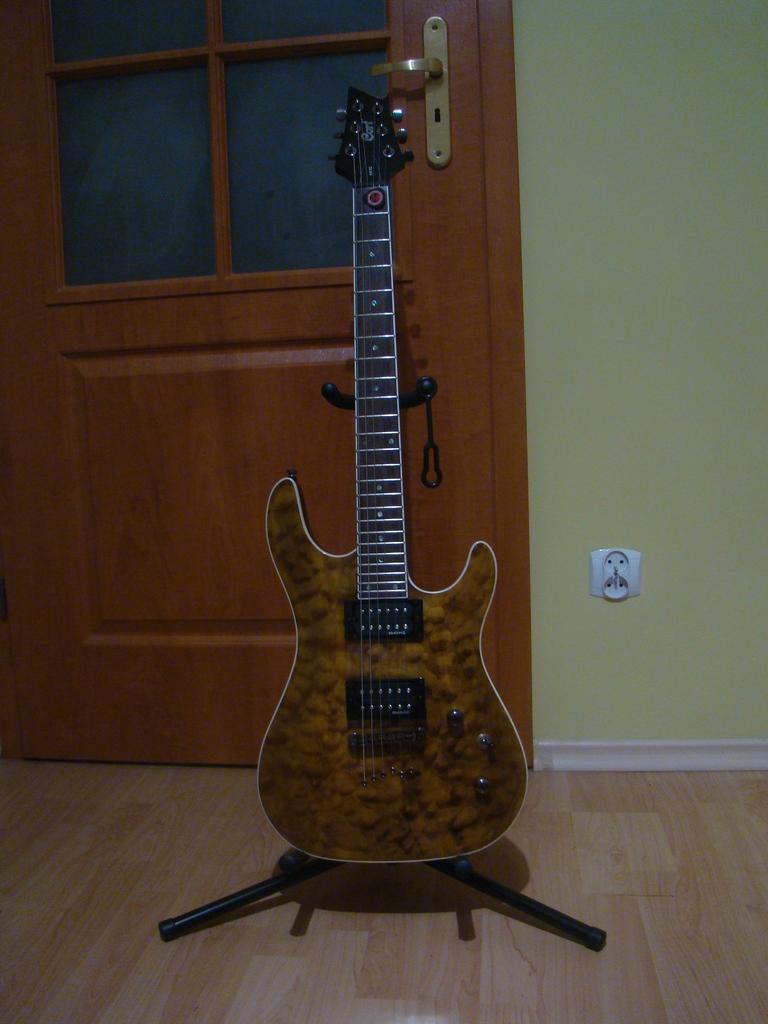Could you give a brief overview of what you see in this image? In the picture we can see a guitar placed on the stand on the wooden mat floor and behind the guitar we can see a door which is of wood and some glasses to it and beside to it we can see a wall with a switchboard. 